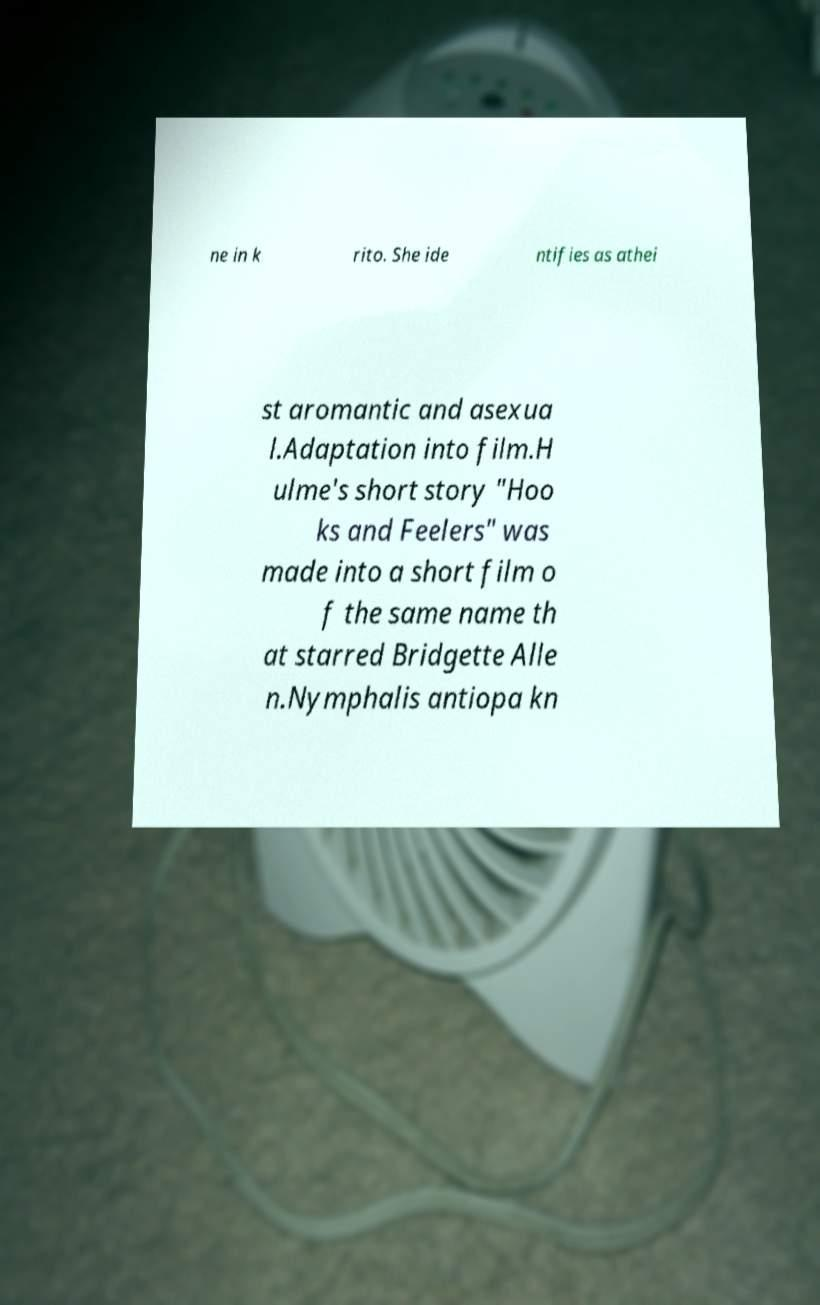Can you accurately transcribe the text from the provided image for me? ne in k rito. She ide ntifies as athei st aromantic and asexua l.Adaptation into film.H ulme's short story "Hoo ks and Feelers" was made into a short film o f the same name th at starred Bridgette Alle n.Nymphalis antiopa kn 